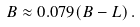Convert formula to latex. <formula><loc_0><loc_0><loc_500><loc_500>B \approx 0 . 0 7 9 ( B - L ) \, .</formula> 